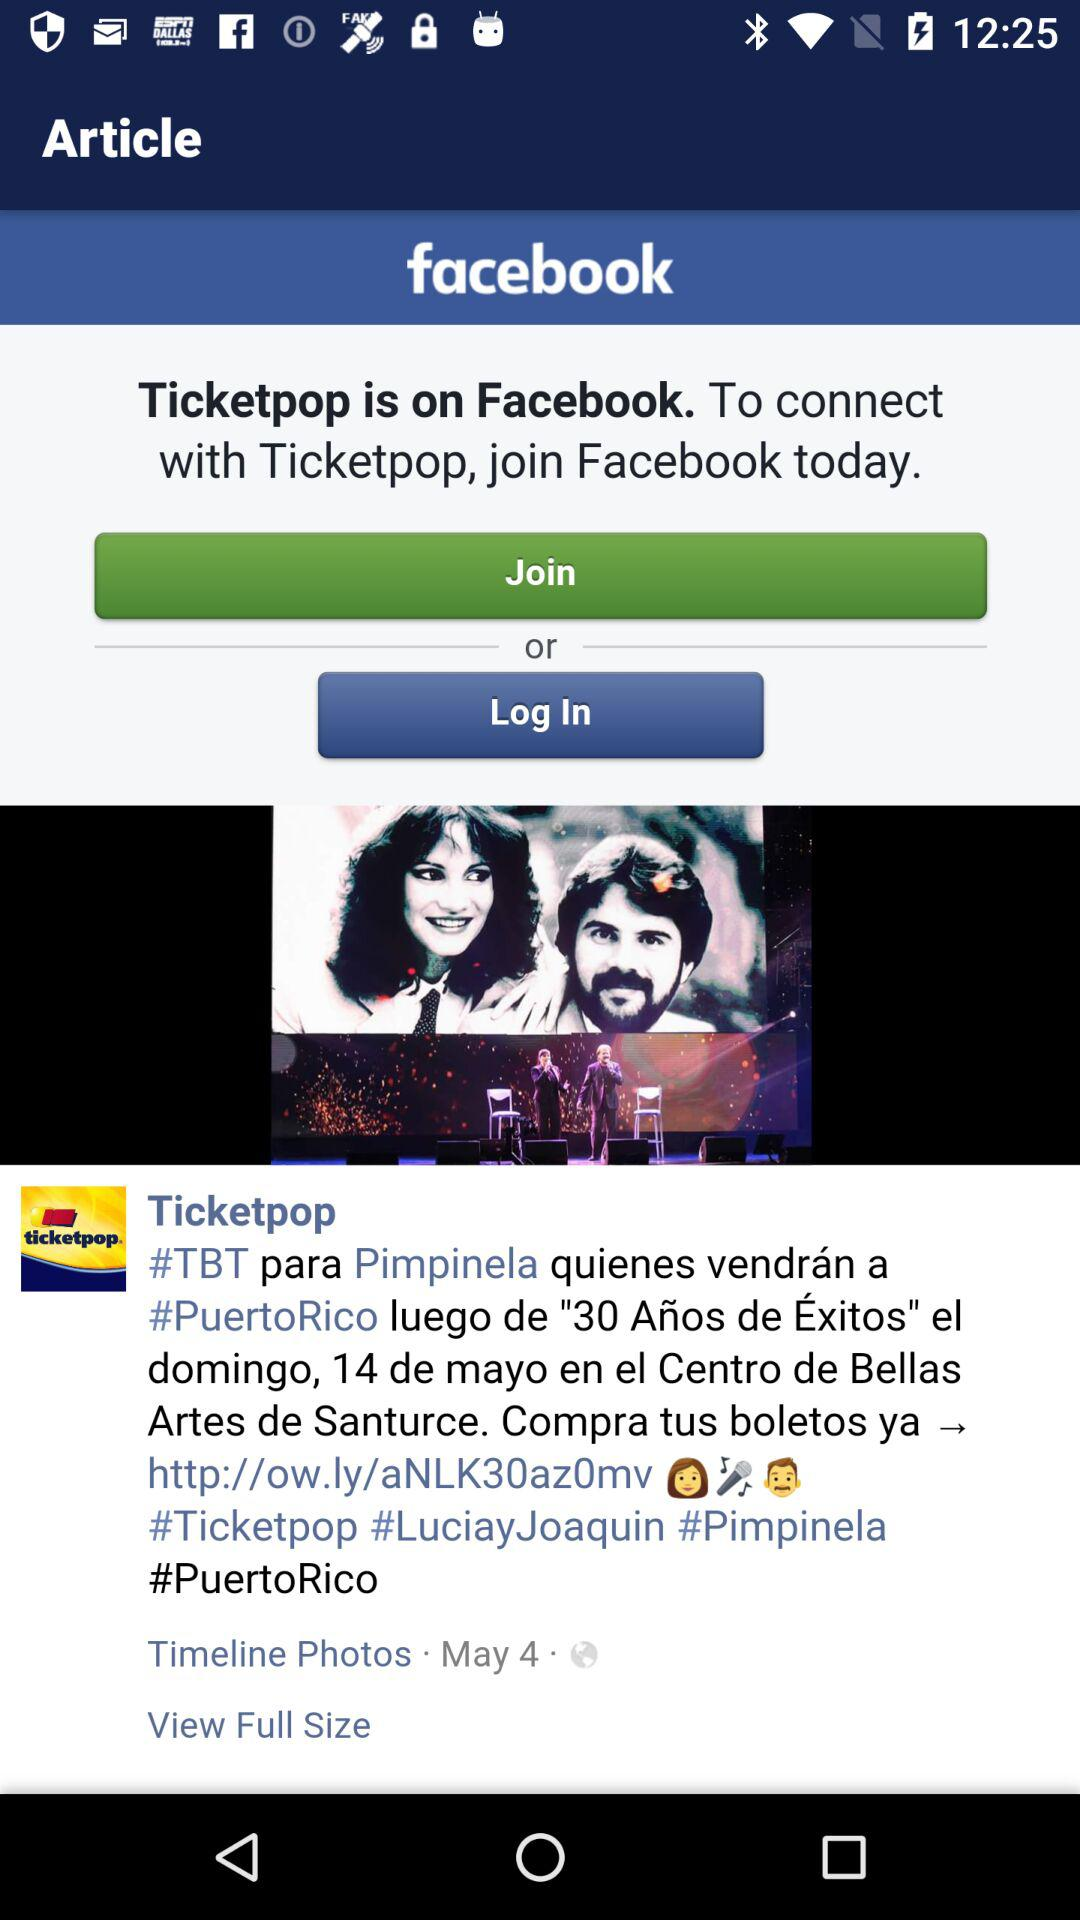What application is available on Facebook? The application that is available on Facebook is "Ticketpop". 